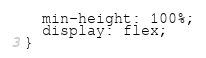<code> <loc_0><loc_0><loc_500><loc_500><_CSS_>  min-height: 100%;
  display: flex;
}
</code> 